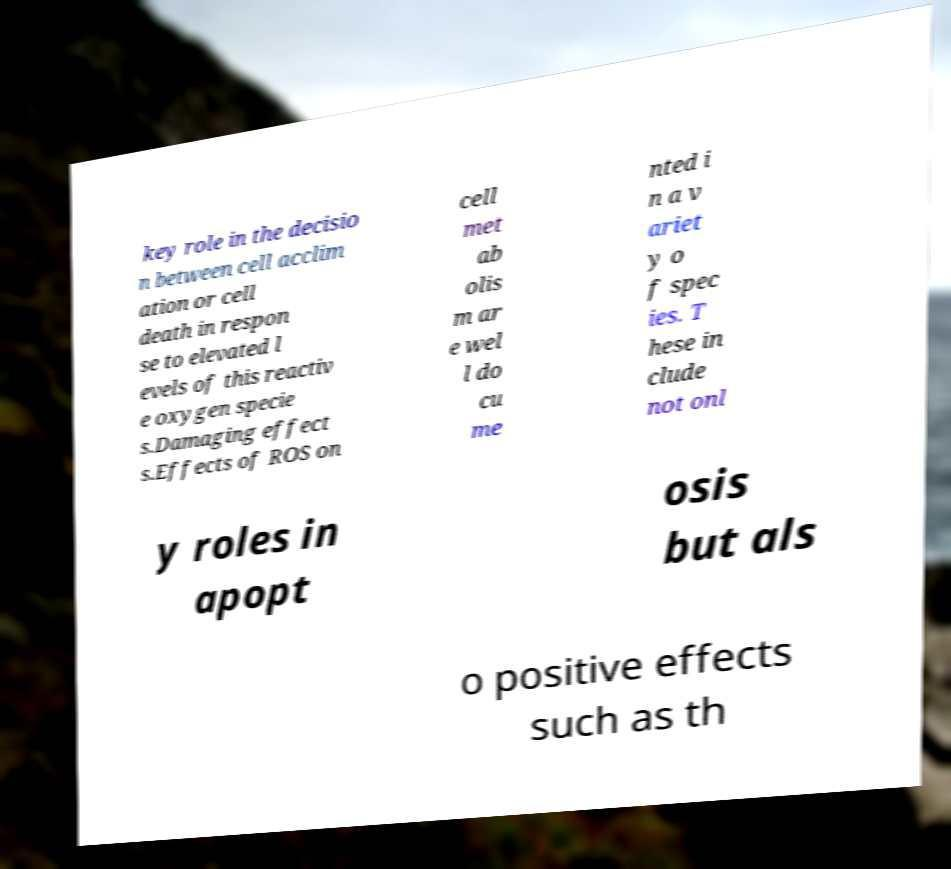What messages or text are displayed in this image? I need them in a readable, typed format. key role in the decisio n between cell acclim ation or cell death in respon se to elevated l evels of this reactiv e oxygen specie s.Damaging effect s.Effects of ROS on cell met ab olis m ar e wel l do cu me nted i n a v ariet y o f spec ies. T hese in clude not onl y roles in apopt osis but als o positive effects such as th 